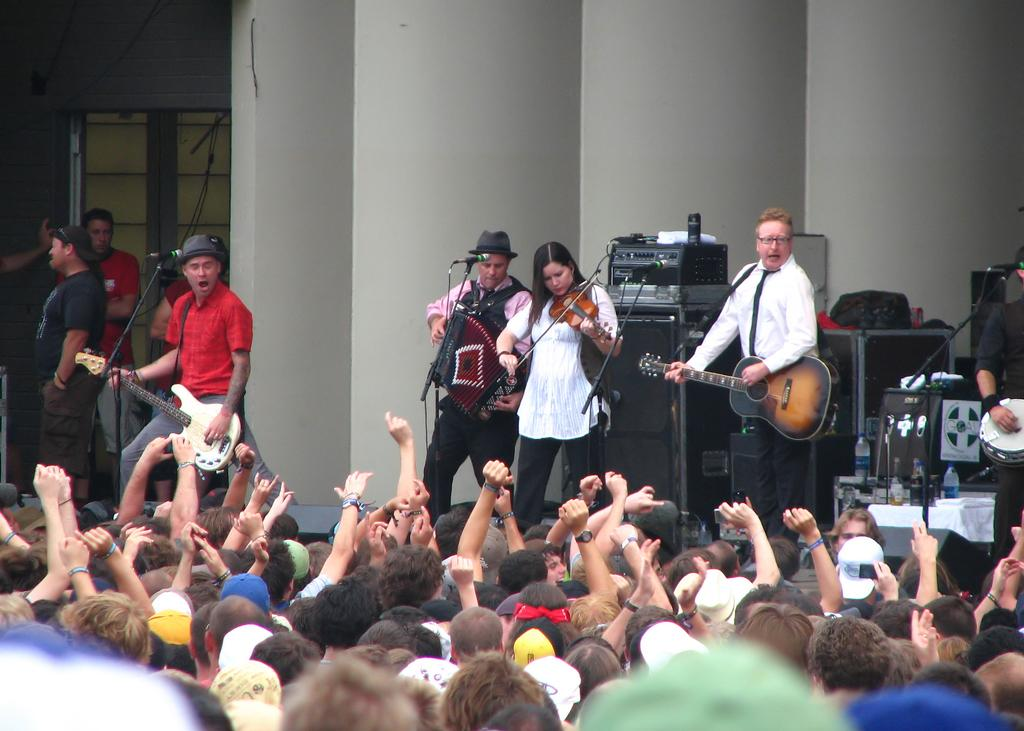What are the people in the image doing? The people in the image are playing musical instruments. What can be seen behind the musicians? There are speakers behind the people playing instruments. Who is observing the musicians? People are watching the musicians in the front. What type of teeth can be seen on the man in the image? There is no man present in the image, and therefore no teeth can be observed. How many fingers does the finger in the image have? There is no finger present in the image, so it is not possible to determine the number of fingers. 